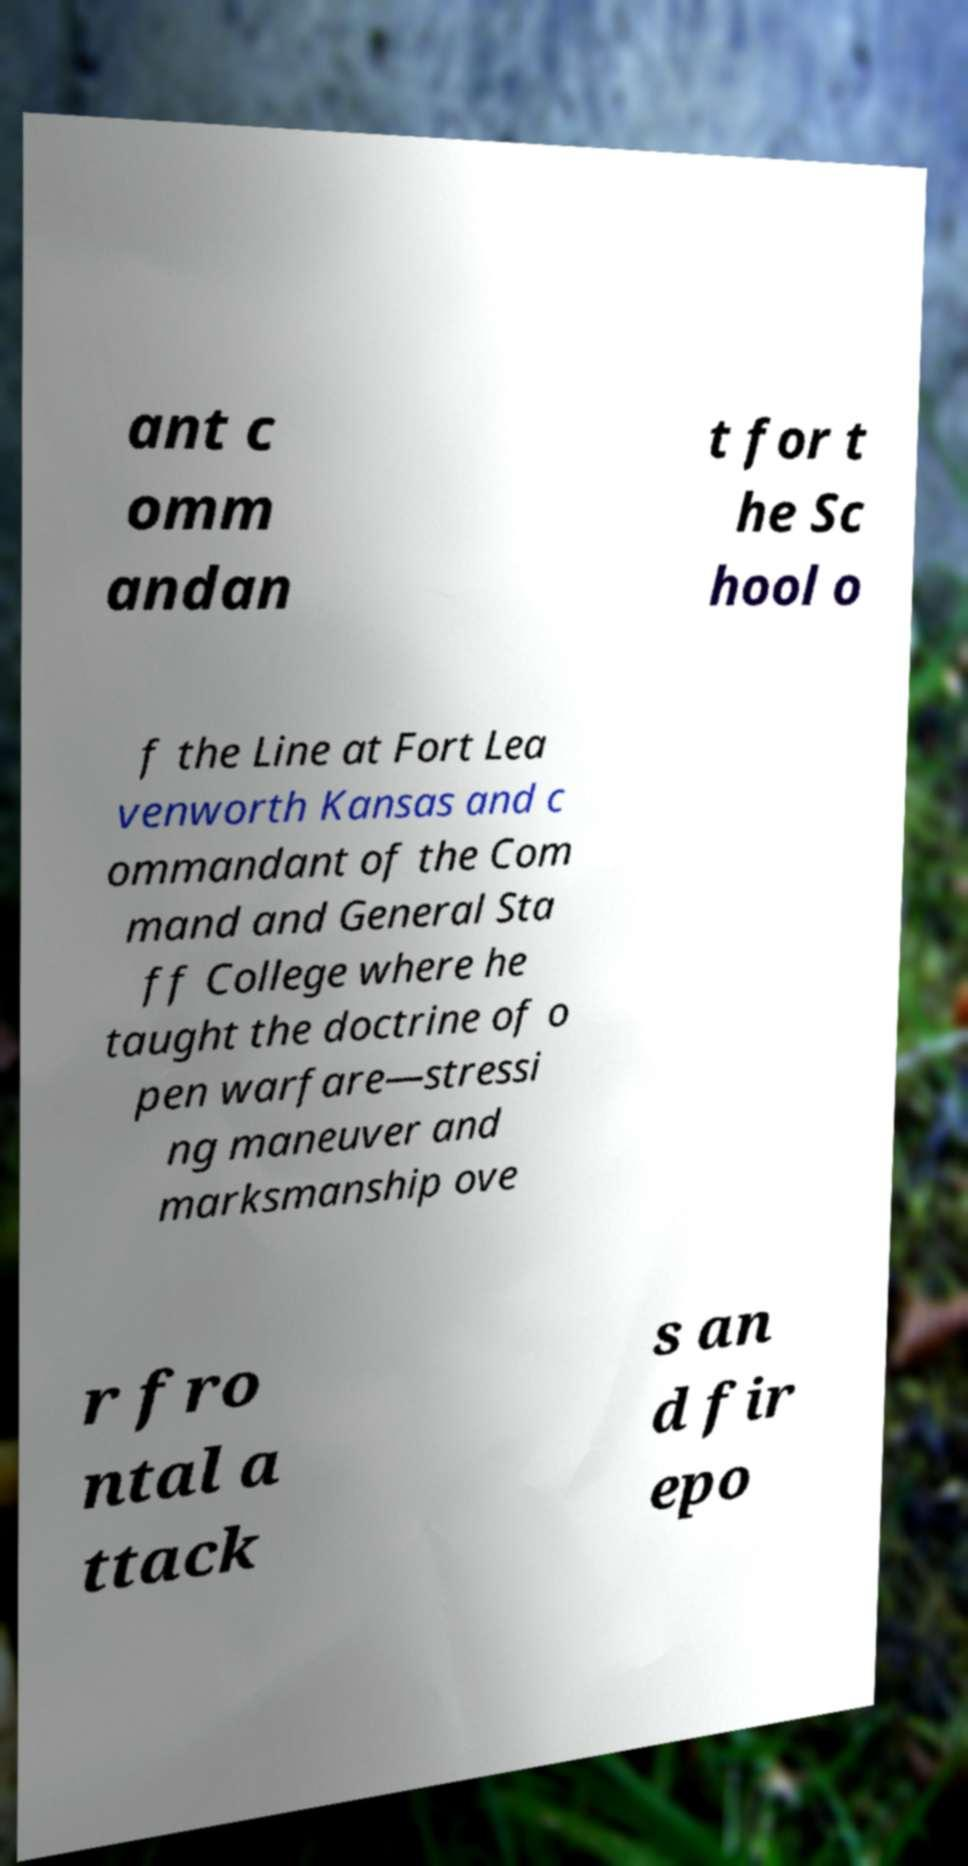Please identify and transcribe the text found in this image. ant c omm andan t for t he Sc hool o f the Line at Fort Lea venworth Kansas and c ommandant of the Com mand and General Sta ff College where he taught the doctrine of o pen warfare—stressi ng maneuver and marksmanship ove r fro ntal a ttack s an d fir epo 